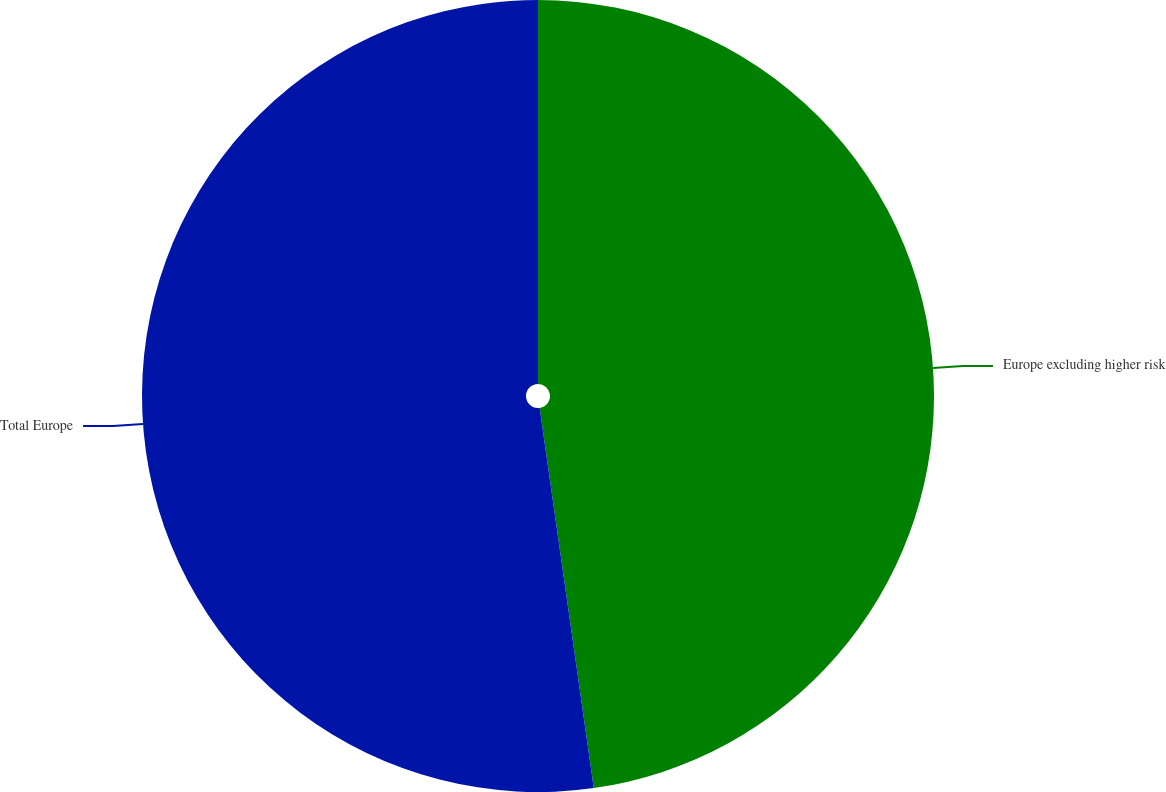Convert chart to OTSL. <chart><loc_0><loc_0><loc_500><loc_500><pie_chart><fcel>Europe excluding higher risk<fcel>Total Europe<nl><fcel>47.75%<fcel>52.25%<nl></chart> 